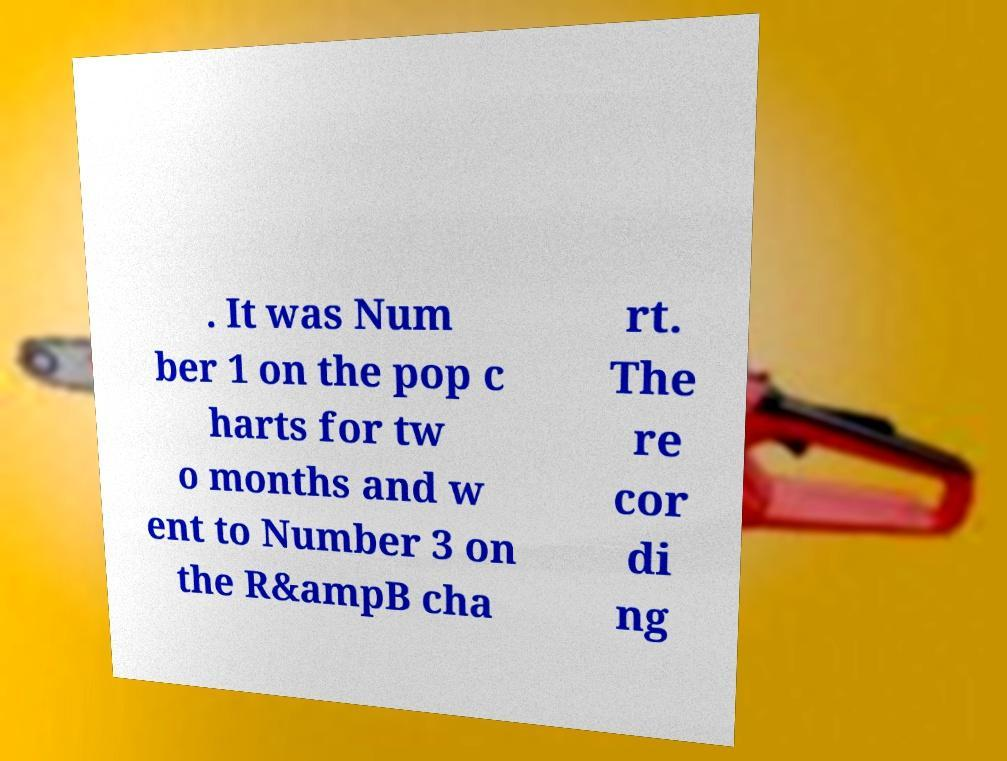Could you extract and type out the text from this image? . It was Num ber 1 on the pop c harts for tw o months and w ent to Number 3 on the R&ampB cha rt. The re cor di ng 